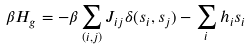Convert formula to latex. <formula><loc_0><loc_0><loc_500><loc_500>\beta H _ { g } = - \beta \sum _ { ( i , j ) } J _ { i j } \delta ( s _ { i } , s _ { j } ) - \sum _ { i } h _ { i } s _ { i }</formula> 